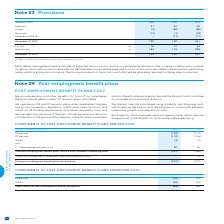According to Bce's financial document, What does 'Other' include? environmental, vacant space and legal provisions. The document states: "(1) Other includes environmental, vacant space and legal provisions...." Also, What do the AROs reflect? management’s best estimates of expected future costs to restore current leased premises to their original condition prior to lease inception. The document states: "AROs reflect management’s best estimates of expected future costs to restore current leased premises to their original condition prior to lease incept..." Also, What are the types of provisions within the table?  The document shows two values: AROs and Other. From the document: "FOR THE YEAR ENDED DECEMBER 31 NOTE AROs OTHER (1) TOTAL FOR THE YEAR ENDED DECEMBER 31 NOTE AROs OTHER (1) TOTAL..." Also, How many components of provisions are accounted for? Counting the relevant items in the document: Additions, Usage, Reversals, Adoption of IFRS 16, I find 4 instances. The key data points involved are: Additions, Adoption of IFRS 16, Reversals. Also, can you calculate: What is the difference in the amount of non-current provisions between AROs and Other? Based on the calculation: 183-115, the result is 68. This is based on the information: "Non-current 25 183 115 298 Non-current 25 183 115 298..." The key data points involved are: 115, 183. Also, can you calculate: What is the ratio of non-current provisions for AROs over that of Other? Based on the calculation: 183/115, the result is 1.59. This is based on the information: "Non-current 25 183 115 298 Non-current 25 183 115 298..." The key data points involved are: 115, 183. 